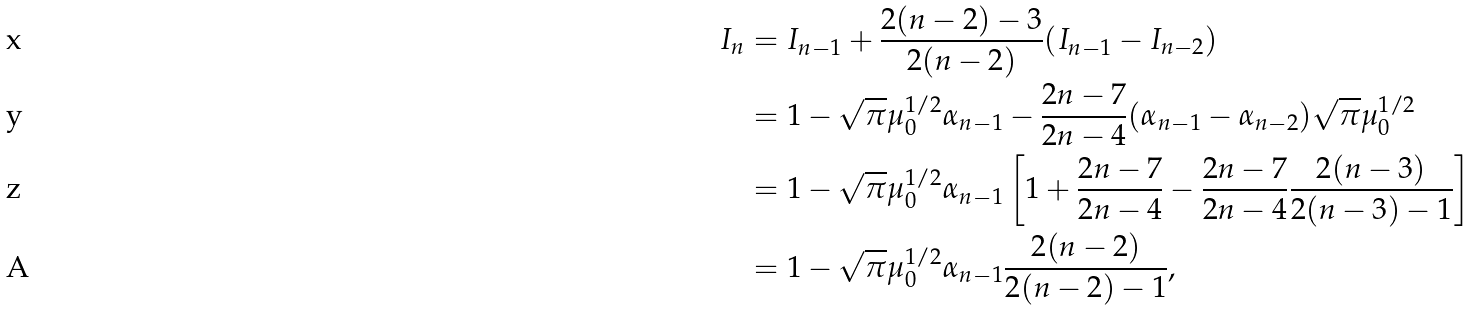Convert formula to latex. <formula><loc_0><loc_0><loc_500><loc_500>I _ { n } & = I _ { n - 1 } + \frac { 2 ( n - 2 ) - 3 } { 2 ( n - 2 ) } ( I _ { n - 1 } - I _ { n - 2 } ) \\ & = 1 - \sqrt { \pi } \mu _ { 0 } ^ { 1 / 2 } \alpha _ { n - 1 } - \frac { 2 n - 7 } { 2 n - 4 } ( \alpha _ { n - 1 } - \alpha _ { n - 2 } ) \sqrt { \pi } \mu _ { 0 } ^ { 1 / 2 } \\ & = 1 - \sqrt { \pi } \mu _ { 0 } ^ { 1 / 2 } \alpha _ { n - 1 } \left [ 1 + \frac { 2 n - 7 } { 2 n - 4 } - \frac { 2 n - 7 } { 2 n - 4 } \frac { 2 ( n - 3 ) } { 2 ( n - 3 ) - 1 } \right ] \\ & = 1 - \sqrt { \pi } \mu _ { 0 } ^ { 1 / 2 } \alpha _ { n - 1 } \frac { 2 ( n - 2 ) } { 2 ( n - 2 ) - 1 } ,</formula> 